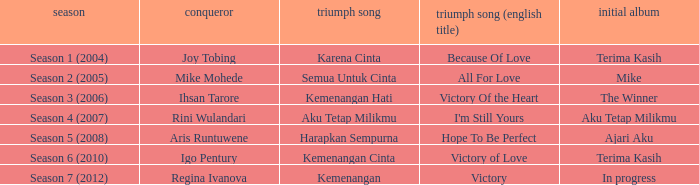Which winning song was sung by aku tetap milikmu? I'm Still Yours. 